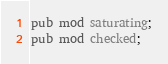Convert code to text. <code><loc_0><loc_0><loc_500><loc_500><_Rust_>pub mod saturating;
pub mod checked;
</code> 